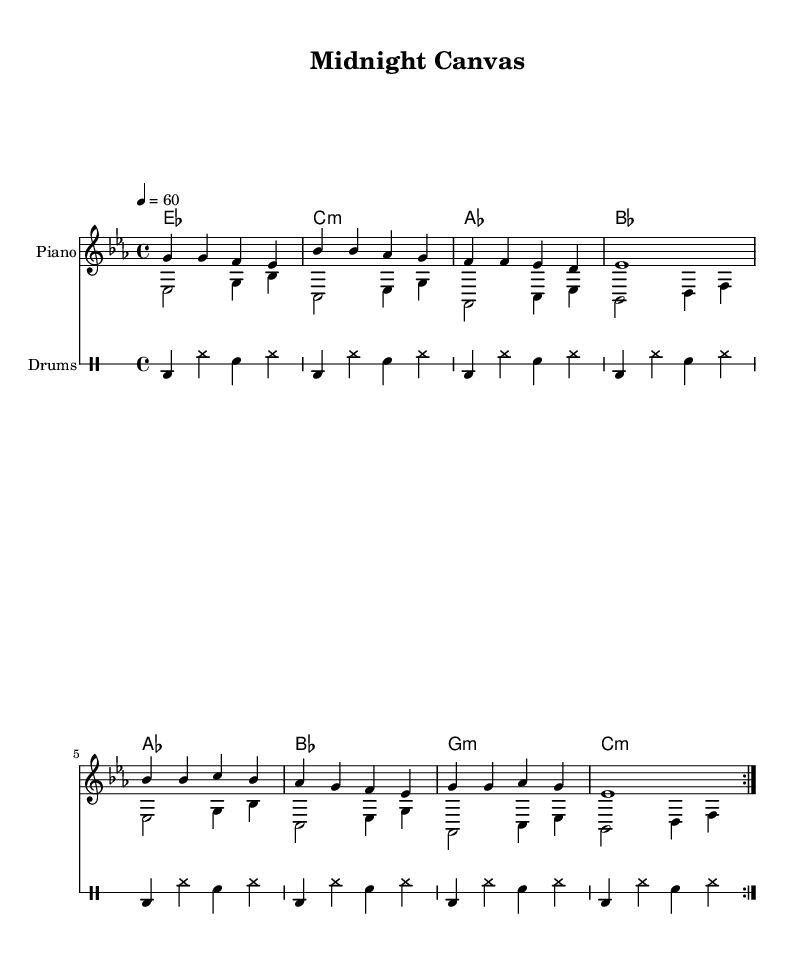What is the key signature of this music? The key signature indicates the presence of three flats, which corresponds to E flat major or C minor. Based on the context of the piece, it is likely E flat major.
Answer: E flat major What is the time signature of this music? The time signature is indicated at the beginning of the score. It shows the division of beats in a measure, which is 4 beats per measure in this piece. This is clearly noted as 4/4.
Answer: 4/4 What is the tempo marking for this piece? The tempo marking gives the speed at which the piece should be played, indicated as "4 = 60". This means it is to be played at 60 beats per minute.
Answer: 60 How many times is the main melody repeated? The repeat signs (volta) at the beginning indicate that the melody is played two times before continuing further in the piece.
Answer: 2 What is the length of the first measure in beats? The first measure consists of four quarter notes, each counting as one beat; therefore, the total length is 4 beats.
Answer: 4 What chord follows the E flat major chord in the chord progression? Analyzing the chord progression, after the E flat major chord, the following chord is a C minor chord as indicated in the second measure.
Answer: C minor What instrument is indicated for the melody line? The score layout specifies that the melody is to be played on the piano, which is explicitly mentioned at the start of the staff.
Answer: Piano 